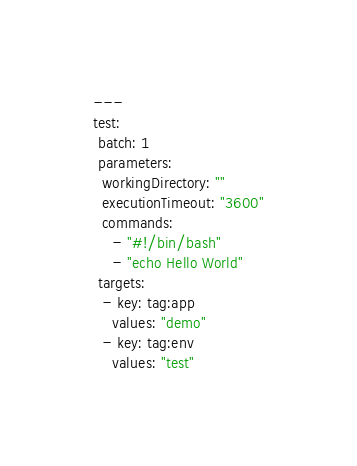Convert code to text. <code><loc_0><loc_0><loc_500><loc_500><_YAML_>---
test:
 batch: 1
 parameters:
  workingDirectory: ""
  executionTimeout: "3600"
  commands:
    - "#!/bin/bash"
    - "echo Hello World"
 targets:
  - key: tag:app
    values: "demo"
  - key: tag:env
    values: "test"
</code> 